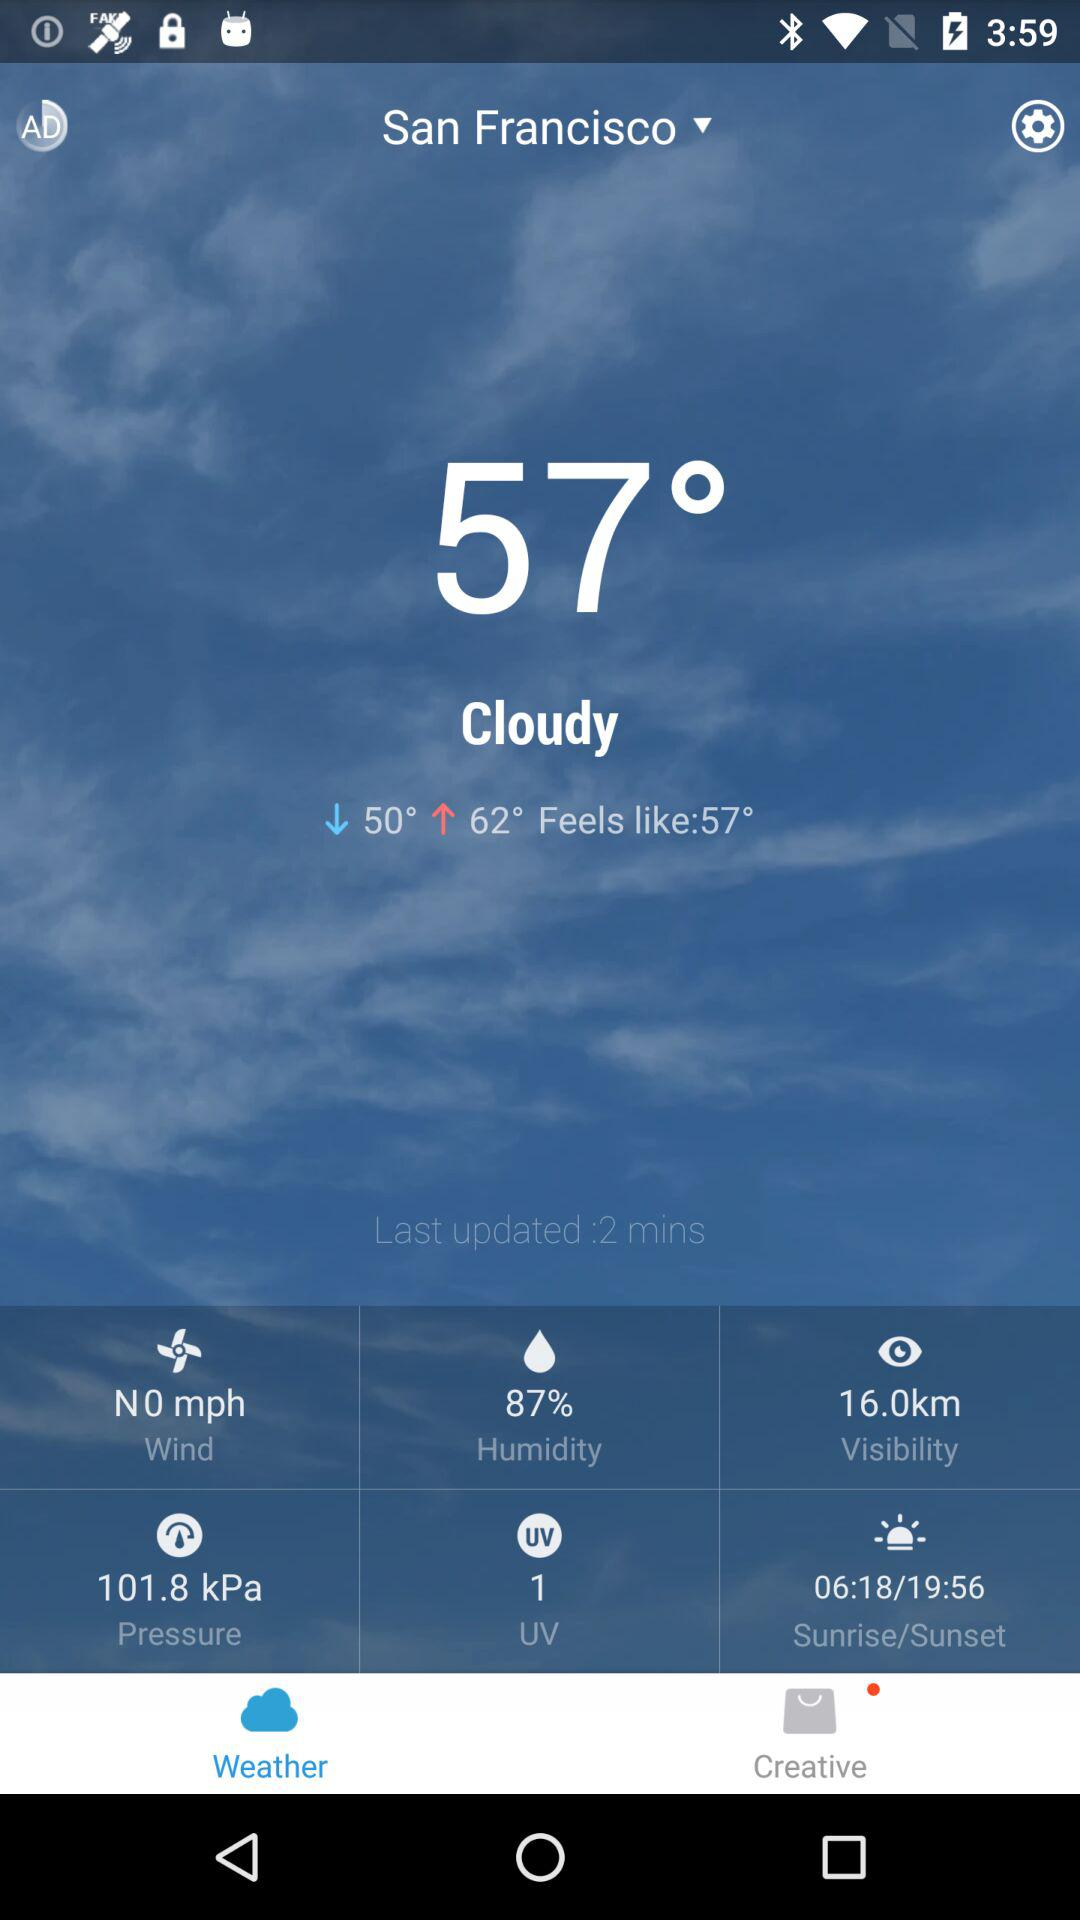What is the humidity percentage?
Answer the question using a single word or phrase. 87% 